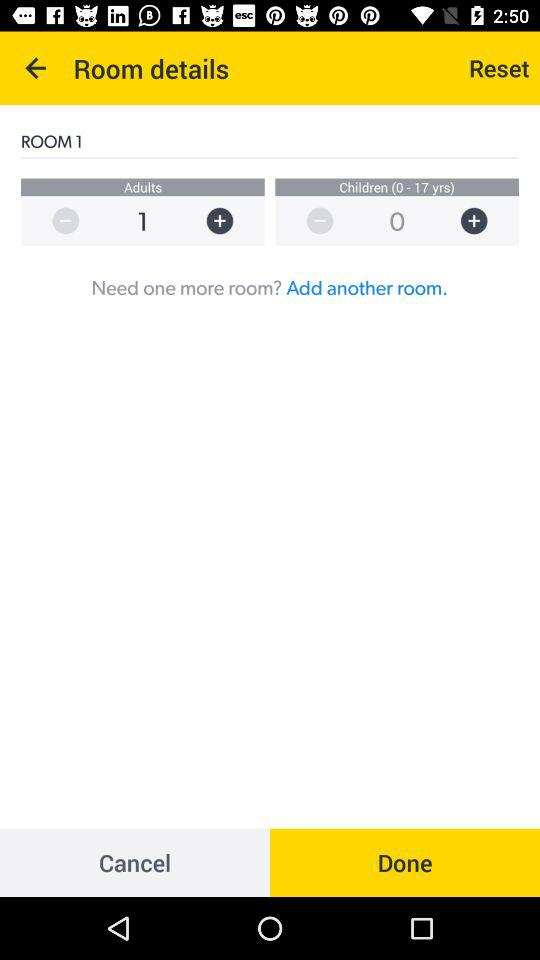How many rooms are there?
Answer the question using a single word or phrase. 1 